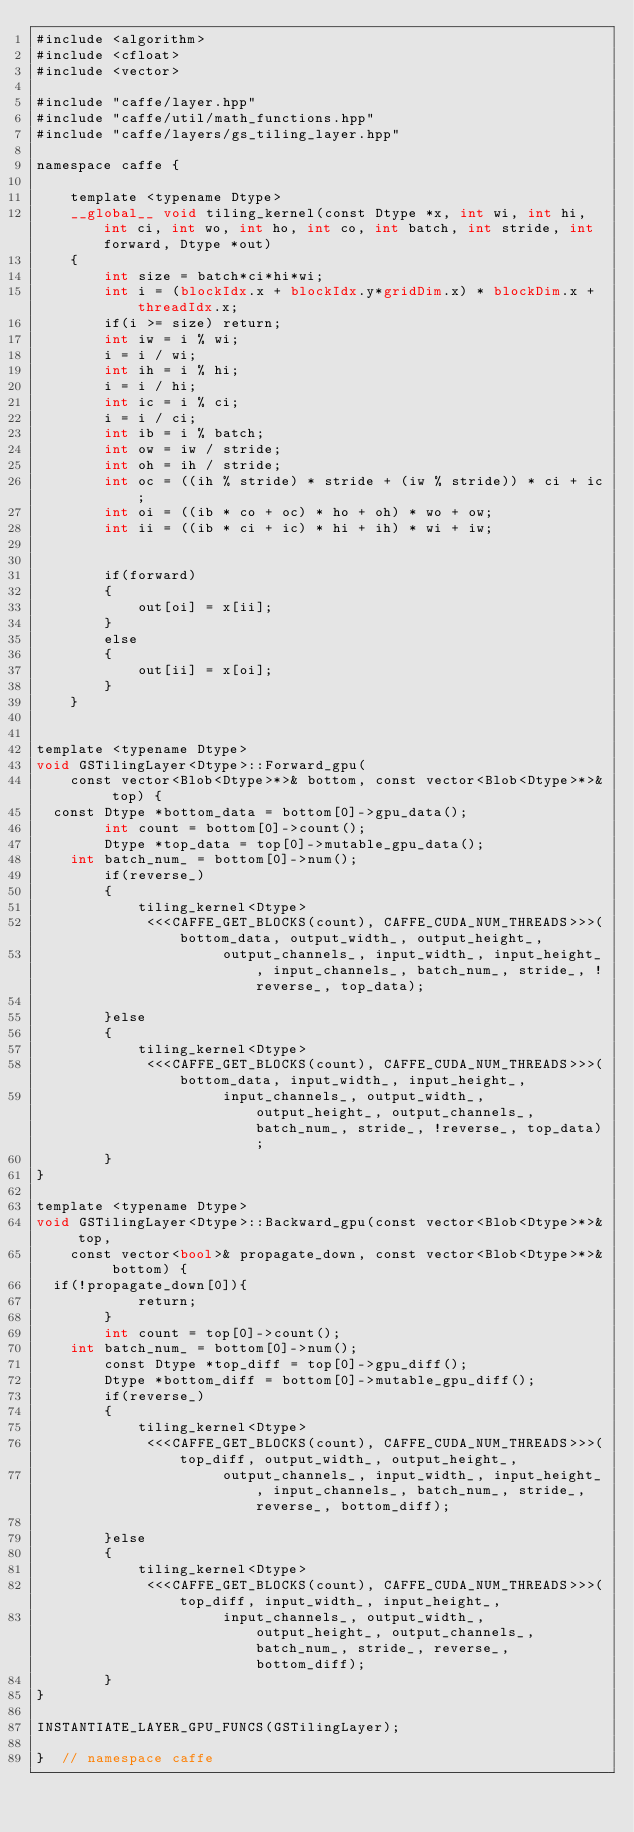<code> <loc_0><loc_0><loc_500><loc_500><_Cuda_>#include <algorithm>
#include <cfloat>
#include <vector>

#include "caffe/layer.hpp"
#include "caffe/util/math_functions.hpp"
#include "caffe/layers/gs_tiling_layer.hpp"

namespace caffe {

    template <typename Dtype>
    __global__ void tiling_kernel(const Dtype *x, int wi, int hi, int ci, int wo, int ho, int co, int batch, int stride, int forward, Dtype *out)
    {
        int size = batch*ci*hi*wi;
        int i = (blockIdx.x + blockIdx.y*gridDim.x) * blockDim.x + threadIdx.x;
        if(i >= size) return;
        int iw = i % wi;
        i = i / wi;
        int ih = i % hi;
        i = i / hi;
        int ic = i % ci;
        i = i / ci;
        int ib = i % batch;
        int ow = iw / stride;
        int oh = ih / stride;
        int oc = ((ih % stride) * stride + (iw % stride)) * ci + ic;
        int oi = ((ib * co + oc) * ho + oh) * wo + ow;
        int ii = ((ib * ci + ic) * hi + ih) * wi + iw;


        if(forward)
        {
            out[oi] = x[ii];
        }         
        else
        {
            out[ii] = x[oi];
        }
    }


template <typename Dtype>
void GSTilingLayer<Dtype>::Forward_gpu(
    const vector<Blob<Dtype>*>& bottom, const vector<Blob<Dtype>*>& top) {
  const Dtype *bottom_data = bottom[0]->gpu_data();
        int count = bottom[0]->count();
        Dtype *top_data = top[0]->mutable_gpu_data();
	int batch_num_ = bottom[0]->num();
        if(reverse_)
        {
	        tiling_kernel<Dtype>
	         <<<CAFFE_GET_BLOCKS(count), CAFFE_CUDA_NUM_THREADS>>>(bottom_data, output_width_, output_height_,
	                  output_channels_, input_width_, input_height_, input_channels_, batch_num_, stride_, !reverse_, top_data);

        }else
	    {
	        tiling_kernel<Dtype>
	         <<<CAFFE_GET_BLOCKS(count), CAFFE_CUDA_NUM_THREADS>>>(bottom_data, input_width_, input_height_,
	                  input_channels_, output_width_, output_height_, output_channels_, batch_num_, stride_, !reverse_, top_data);
	    }
}

template <typename Dtype>
void GSTilingLayer<Dtype>::Backward_gpu(const vector<Blob<Dtype>*>& top,
    const vector<bool>& propagate_down, const vector<Blob<Dtype>*>& bottom) {
  if(!propagate_down[0]){
            return;
        }
        int count = top[0]->count();
	int batch_num_ = bottom[0]->num();
        const Dtype *top_diff = top[0]->gpu_diff();
        Dtype *bottom_diff = bottom[0]->mutable_gpu_diff();
        if(reverse_)
        {
	        tiling_kernel<Dtype>
	         <<<CAFFE_GET_BLOCKS(count), CAFFE_CUDA_NUM_THREADS>>>(top_diff, output_width_, output_height_,
	                  output_channels_, input_width_, input_height_, input_channels_, batch_num_, stride_, reverse_, bottom_diff);

        }else
	    {
	        tiling_kernel<Dtype>
	         <<<CAFFE_GET_BLOCKS(count), CAFFE_CUDA_NUM_THREADS>>>(top_diff, input_width_, input_height_,
	                  input_channels_, output_width_, output_height_, output_channels_, batch_num_, stride_, reverse_, bottom_diff);
	    }
}

INSTANTIATE_LAYER_GPU_FUNCS(GSTilingLayer);

}  // namespace caffe
</code> 